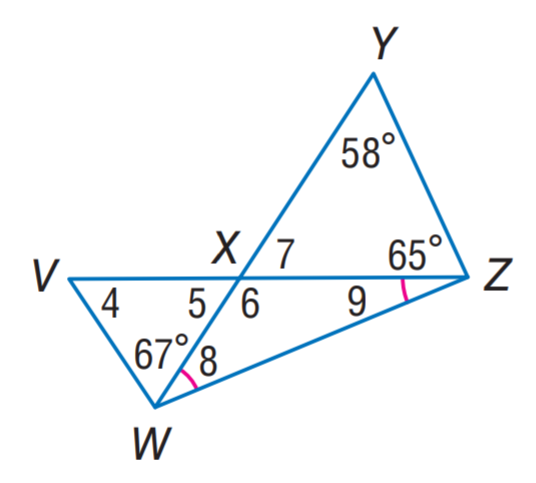Question: Find m \angle 8.
Choices:
A. 28
B. 28.5
C. 56
D. 57
Answer with the letter. Answer: B Question: Find \angle 6.
Choices:
A. 28.5
B. 56
C. 57
D. 123
Answer with the letter. Answer: D Question: Find m \angle 5.
Choices:
A. 28.5
B. 56
C. 57
D. 123
Answer with the letter. Answer: C 